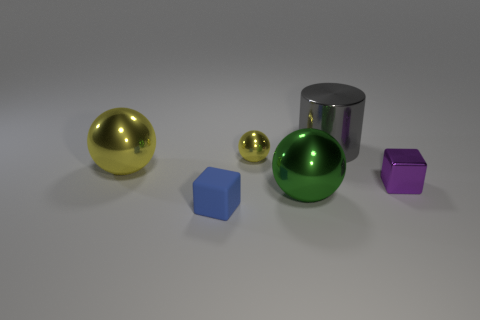Are there any other things that have the same material as the blue thing?
Provide a succinct answer. No. Is there a small cube that has the same material as the large green ball?
Offer a terse response. Yes. There is a thing that is in front of the green sphere; does it have the same shape as the tiny object that is right of the gray metal thing?
Your answer should be compact. Yes. Are there any big yellow cylinders?
Provide a succinct answer. No. What color is the metallic block that is the same size as the blue matte thing?
Make the answer very short. Purple. How many other things are the same shape as the green thing?
Your response must be concise. 2. Does the big sphere right of the large yellow metallic sphere have the same material as the tiny blue thing?
Ensure brevity in your answer.  No. How many spheres are purple metal things or metal objects?
Your answer should be compact. 3. What is the shape of the tiny shiny thing behind the large metal sphere that is behind the metallic object on the right side of the gray shiny thing?
Make the answer very short. Sphere. There is a large thing that is the same color as the tiny metallic ball; what is its shape?
Your answer should be very brief. Sphere. 